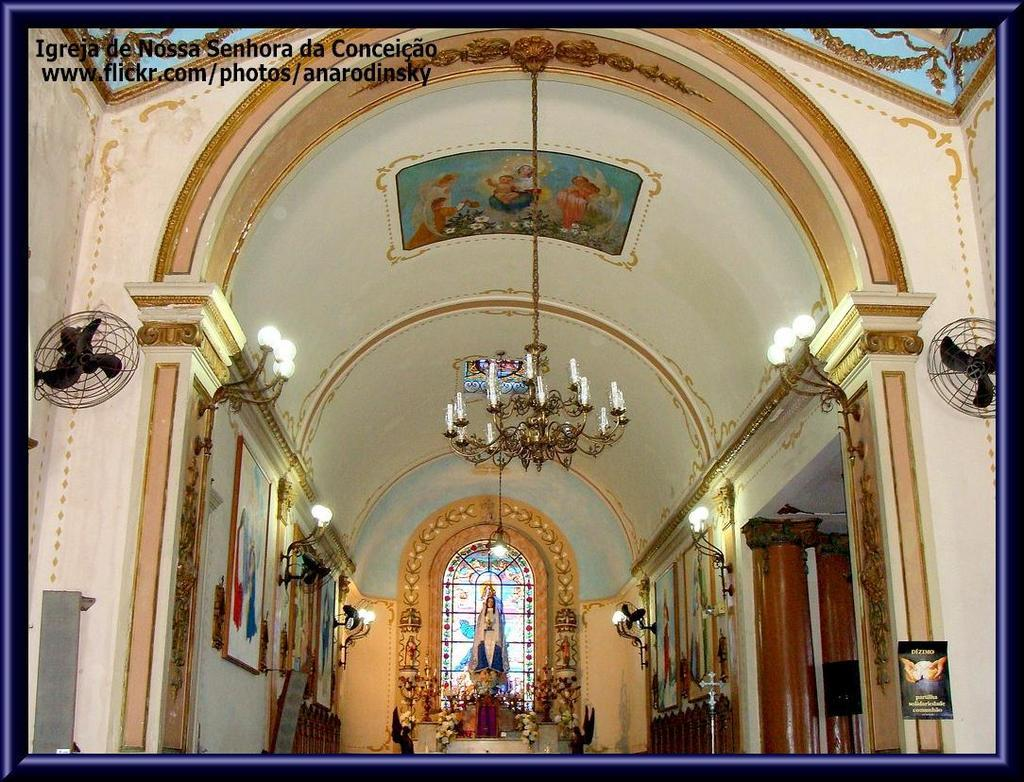What type of structure is visible in the image? There is a building in the image. What type of artwork can be seen in the image? There is a sculpture in the image. What type of decorative items are present in the image? There are frames in the image. What type of lighting is visible in the image? There are lights in the image. What type of natural elements are present in the image? There are flowers in the image. What type of appliances are present in the image? There are fans in the image. What type of architectural feature is visible in the image? There is a wall in the image. What type of ceiling light is visible in the image? There is a ceiling light in the image. What type of note is the son holding in the image? There is no son or note present in the image. What type of straw is used to drink from the sculpture in the image? There is no straw present in the image, as the sculpture is not a container for liquid. 